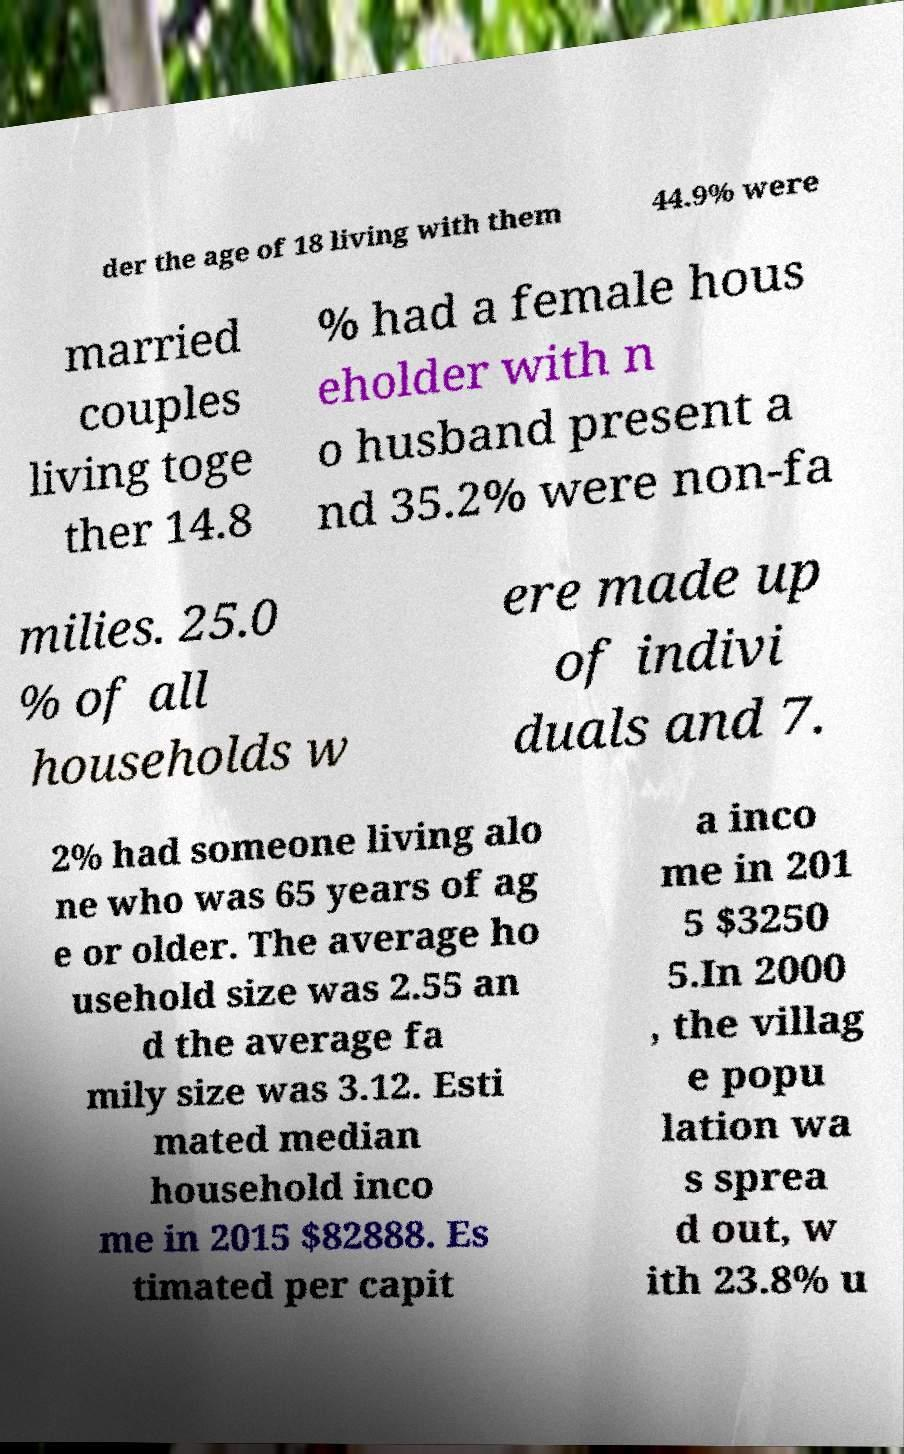Could you assist in decoding the text presented in this image and type it out clearly? der the age of 18 living with them 44.9% were married couples living toge ther 14.8 % had a female hous eholder with n o husband present a nd 35.2% were non-fa milies. 25.0 % of all households w ere made up of indivi duals and 7. 2% had someone living alo ne who was 65 years of ag e or older. The average ho usehold size was 2.55 an d the average fa mily size was 3.12. Esti mated median household inco me in 2015 $82888. Es timated per capit a inco me in 201 5 $3250 5.In 2000 , the villag e popu lation wa s sprea d out, w ith 23.8% u 